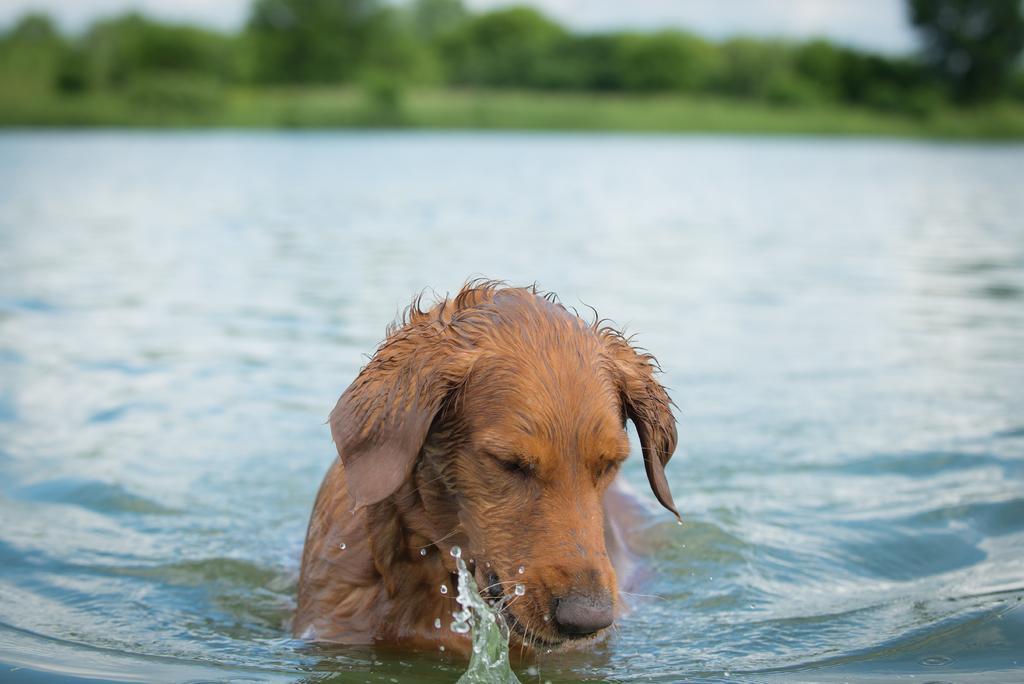How would you summarize this image in a sentence or two? In this image we can see many trees and plants. There is a lake and a dog in the water. There is a sky in the image. 